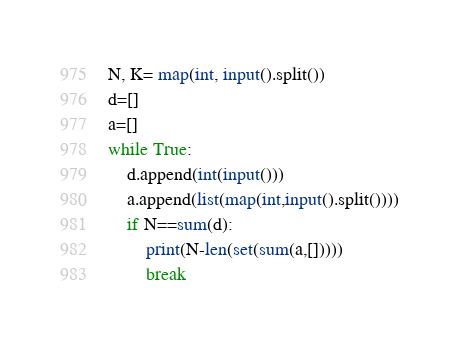<code> <loc_0><loc_0><loc_500><loc_500><_Python_>N, K= map(int, input().split())
d=[]
a=[]
while True:
    d.append(int(input()))
    a.append(list(map(int,input().split())))
    if N==sum(d):
        print(N-len(set(sum(a,[]))))
        break</code> 